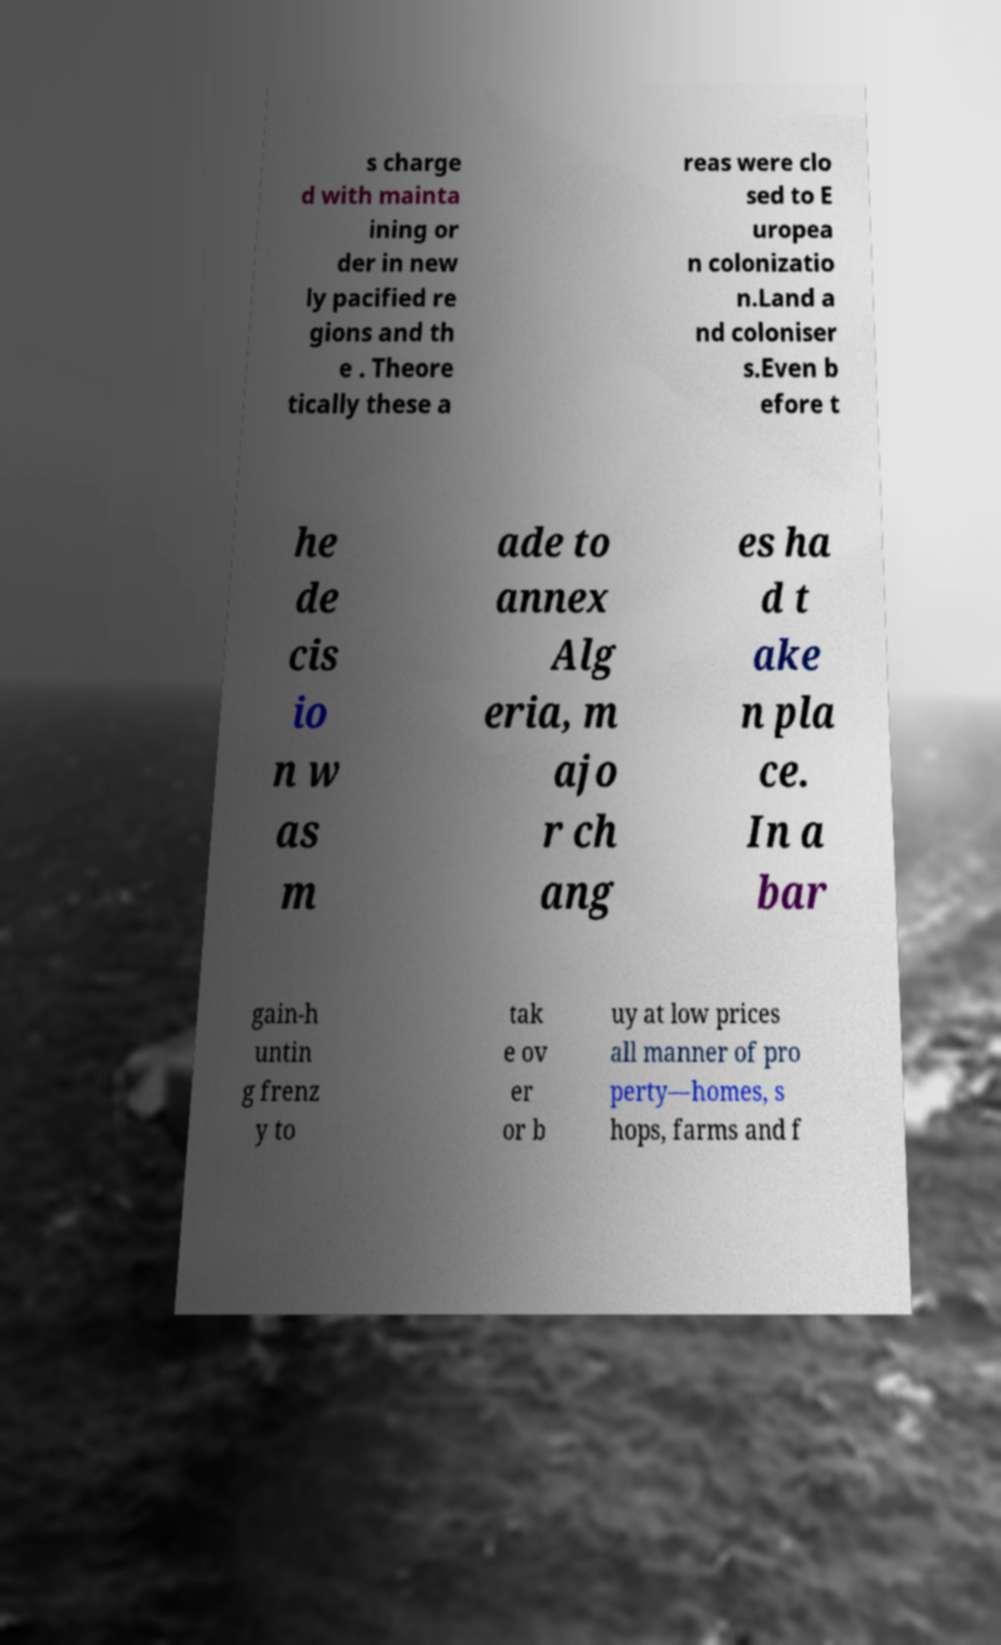What messages or text are displayed in this image? I need them in a readable, typed format. s charge d with mainta ining or der in new ly pacified re gions and th e . Theore tically these a reas were clo sed to E uropea n colonizatio n.Land a nd coloniser s.Even b efore t he de cis io n w as m ade to annex Alg eria, m ajo r ch ang es ha d t ake n pla ce. In a bar gain-h untin g frenz y to tak e ov er or b uy at low prices all manner of pro perty—homes, s hops, farms and f 